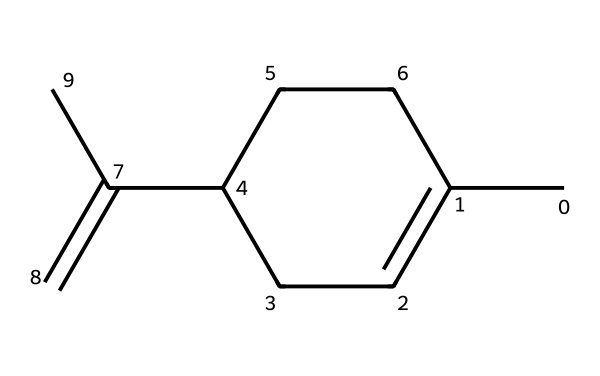What is the name of this chemical? The provided SMILES structure corresponds to limonene, which is a cyclic monoterpene commonly found in citrus fruits.
Answer: limonene How many carbon atoms are present in this molecule? By analyzing the SMILES representation, we can count 10 carbon atoms in total, indicated by the "C" symbols in the structure.
Answer: 10 How many double bonds does limonene have? In the chemical structure visualized from the SMILES, there are two double bonds present. These can be identified by the "=C" symbols in the structure.
Answer: 2 What functional group is characteristic of limonene? Limonene contains a cyclic structure and is characterized by the presence of a double bond and lacks any hydroxyl or aldehyde groups, making it a terpene.
Answer: terpene Is limonene an aldehyde? Limonene does not have the aldehyde functional group (−CHO) present in its structure, so it cannot be classified as an aldehyde.
Answer: no What type of isomerism is possible in limonene? Limonene can exhibit cis-trans isomerism due to the presence of double bonds and the different spatial arrangements of atoms around these bonds.
Answer: cis-trans isomerism How does limonene contribute to the aroma of yuzu? Limonene contributes to the citrusy scent of yuzu as its structure is responsible for the characteristic aromatic properties associated with citrus fruits.
Answer: citrus scent 